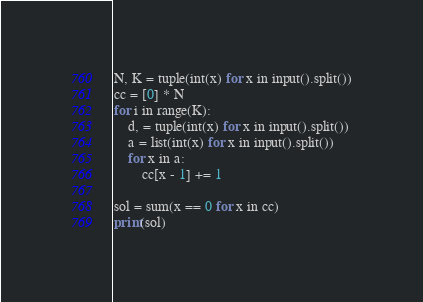Convert code to text. <code><loc_0><loc_0><loc_500><loc_500><_Cython_>N, K = tuple(int(x) for x in input().split())
cc = [0] * N
for i in range(K):
    d, = tuple(int(x) for x in input().split())
    a = list(int(x) for x in input().split())
    for x in a:
        cc[x - 1] += 1

sol = sum(x == 0 for x in cc)
print(sol)
</code> 